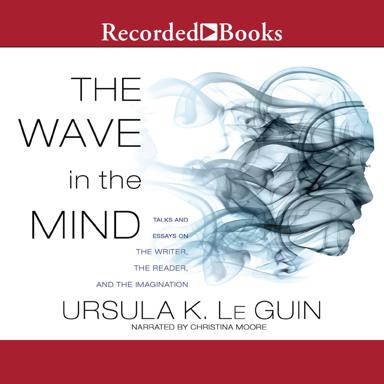What is the title and author of the book mentioned in the image? The book seen in the image is titled 'The Wave in the Mind: Talks and Essays on the Writer, the Reader, and the Imagination', authored by the celebrated writer Ursula K. Le Guin. This collection explores a variety of thoughts on literacy, empathy, and the author's own insightful examinations of storytelling. 